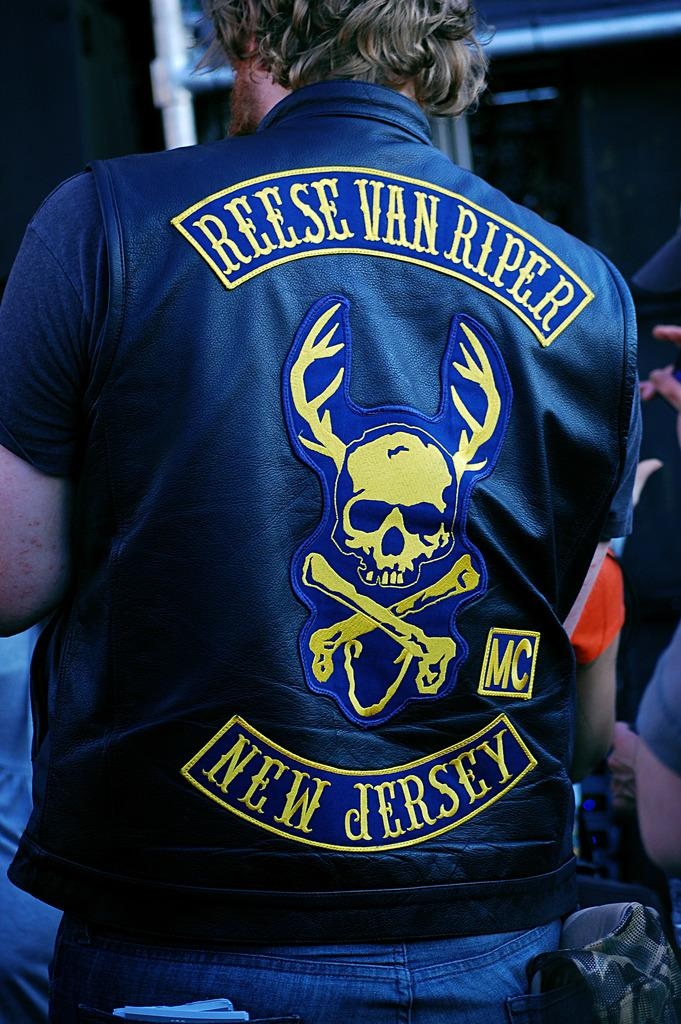<image>
Create a compact narrative representing the image presented. Reese Van Riper is from New Jersey, according to his jacket. 